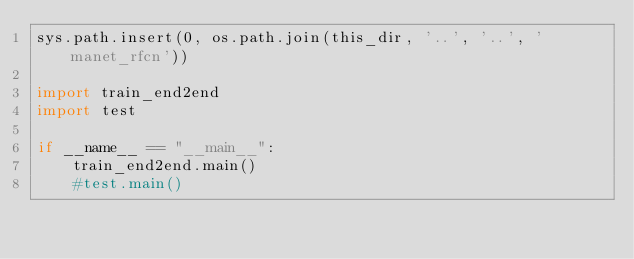<code> <loc_0><loc_0><loc_500><loc_500><_Python_>sys.path.insert(0, os.path.join(this_dir, '..', '..', 'manet_rfcn'))

import train_end2end
import test

if __name__ == "__main__":
    train_end2end.main()
    #test.main()




</code> 